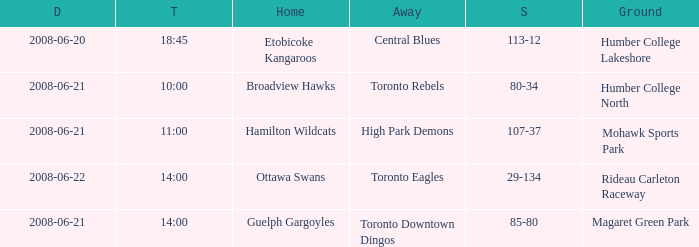What is the Date with a Home that is hamilton wildcats? 2008-06-21. Could you help me parse every detail presented in this table? {'header': ['D', 'T', 'Home', 'Away', 'S', 'Ground'], 'rows': [['2008-06-20', '18:45', 'Etobicoke Kangaroos', 'Central Blues', '113-12', 'Humber College Lakeshore'], ['2008-06-21', '10:00', 'Broadview Hawks', 'Toronto Rebels', '80-34', 'Humber College North'], ['2008-06-21', '11:00', 'Hamilton Wildcats', 'High Park Demons', '107-37', 'Mohawk Sports Park'], ['2008-06-22', '14:00', 'Ottawa Swans', 'Toronto Eagles', '29-134', 'Rideau Carleton Raceway'], ['2008-06-21', '14:00', 'Guelph Gargoyles', 'Toronto Downtown Dingos', '85-80', 'Magaret Green Park']]} 